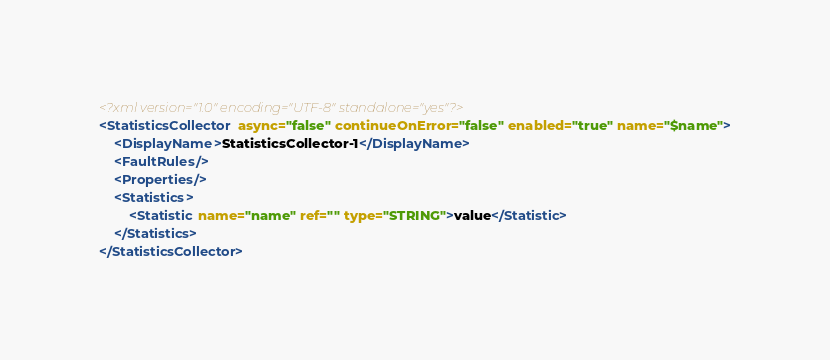<code> <loc_0><loc_0><loc_500><loc_500><_XML_><?xml version="1.0" encoding="UTF-8" standalone="yes"?>
<StatisticsCollector async="false" continueOnError="false" enabled="true" name="$name">
    <DisplayName>StatisticsCollector-1</DisplayName>
    <FaultRules/>
    <Properties/>
    <Statistics>
        <Statistic name="name" ref="" type="STRING">value</Statistic>
    </Statistics>
</StatisticsCollector></code> 